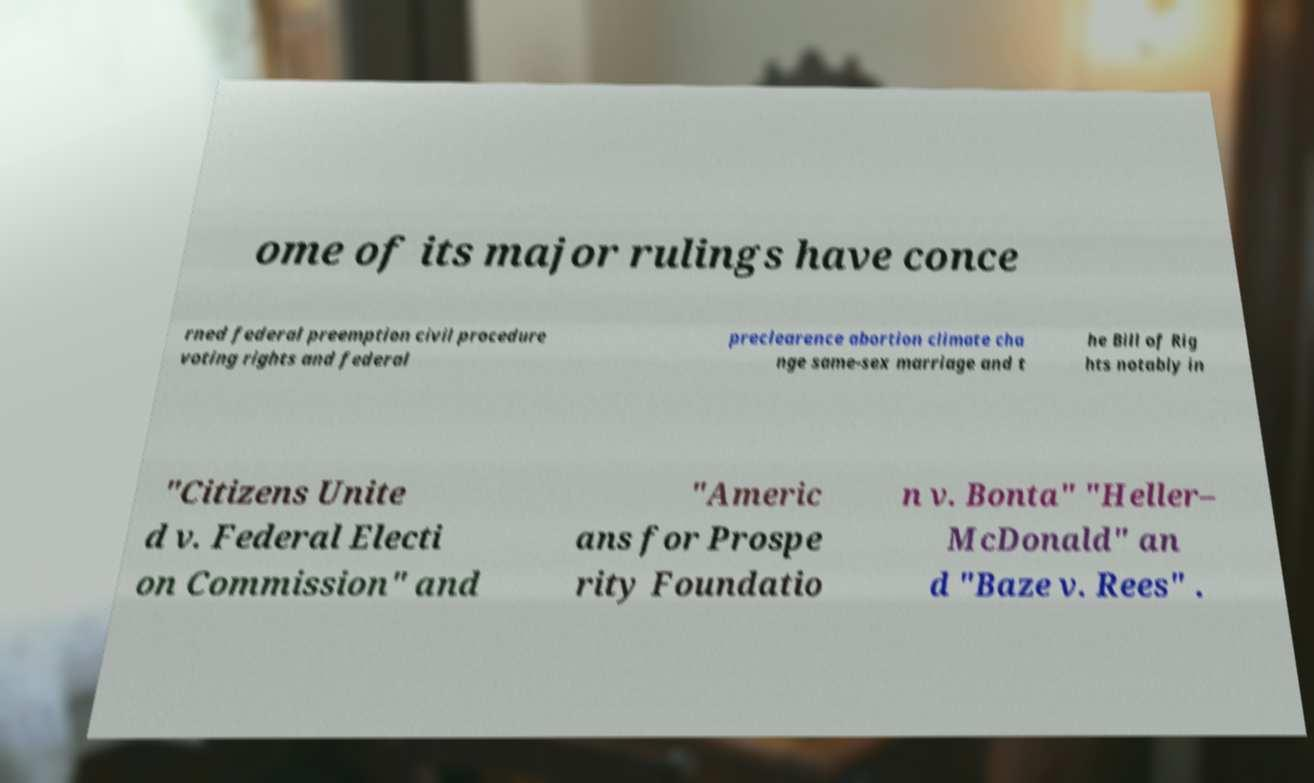Please identify and transcribe the text found in this image. ome of its major rulings have conce rned federal preemption civil procedure voting rights and federal preclearence abortion climate cha nge same-sex marriage and t he Bill of Rig hts notably in "Citizens Unite d v. Federal Electi on Commission" and "Americ ans for Prospe rity Foundatio n v. Bonta" "Heller– McDonald" an d "Baze v. Rees" . 